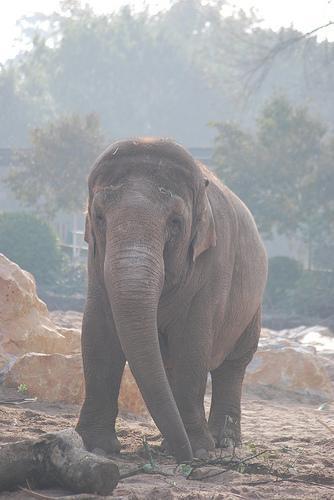How many elephants are shown?
Give a very brief answer. 1. 